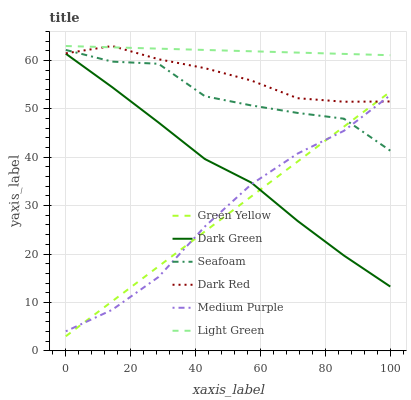Does Green Yellow have the minimum area under the curve?
Answer yes or no. Yes. Does Light Green have the maximum area under the curve?
Answer yes or no. Yes. Does Seafoam have the minimum area under the curve?
Answer yes or no. No. Does Seafoam have the maximum area under the curve?
Answer yes or no. No. Is Green Yellow the smoothest?
Answer yes or no. Yes. Is Seafoam the roughest?
Answer yes or no. Yes. Is Medium Purple the smoothest?
Answer yes or no. No. Is Medium Purple the roughest?
Answer yes or no. No. Does Seafoam have the lowest value?
Answer yes or no. No. Does Seafoam have the highest value?
Answer yes or no. No. Is Dark Green less than Light Green?
Answer yes or no. Yes. Is Seafoam greater than Dark Green?
Answer yes or no. Yes. Does Dark Green intersect Light Green?
Answer yes or no. No. 